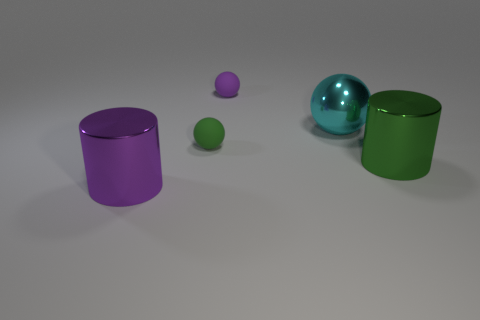Subtract all rubber balls. How many balls are left? 1 Subtract all green cylinders. How many cylinders are left? 1 Subtract 1 cylinders. How many cylinders are left? 1 Subtract all brown balls. How many purple cylinders are left? 1 Add 5 large gray metal cubes. How many objects exist? 10 Subtract all cylinders. How many objects are left? 3 Subtract all small green things. Subtract all purple matte things. How many objects are left? 3 Add 1 green rubber things. How many green rubber things are left? 2 Add 1 large metallic spheres. How many large metallic spheres exist? 2 Subtract 0 gray cylinders. How many objects are left? 5 